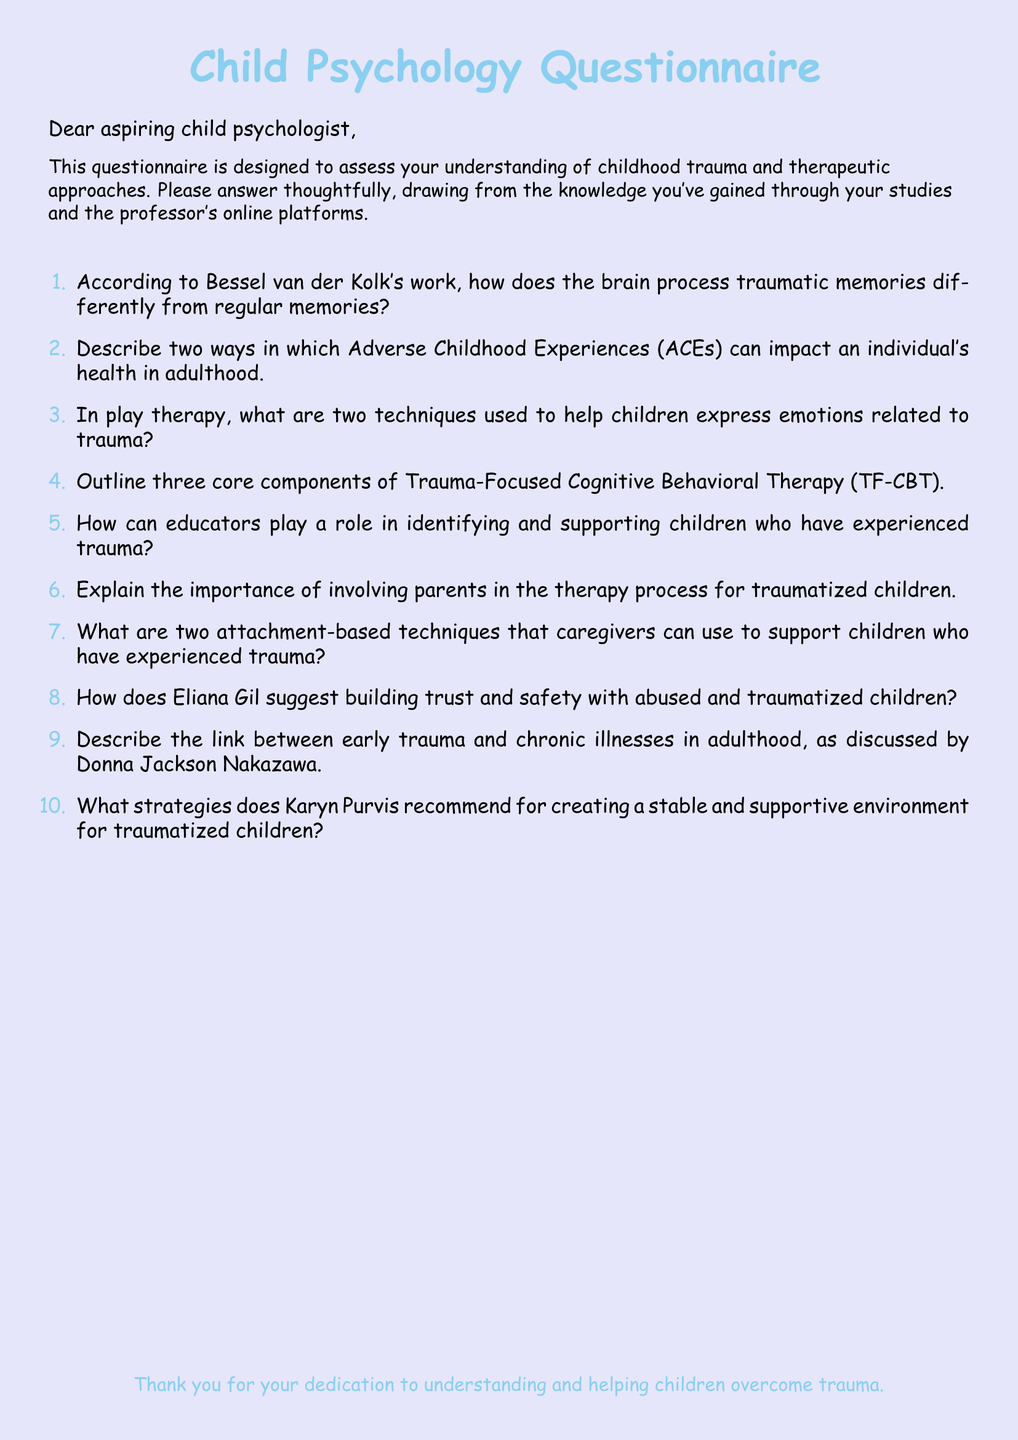What is the title of the document? The title is clearly stated at the beginning of the document, which is "Child Psychology Questionnaire."
Answer: Child Psychology Questionnaire Who is the audience for this questionnaire? The document specifically addresses "aspiring child psychologist," indicating who it is meant for.
Answer: aspiring child psychologist What color is used for the main font? The document uses "Comic Sans MS" as the main font for text.
Answer: Comic Sans MS What are ACEs? The term is mentioned in the context of "Adverse Childhood Experiences," which is abbreviated as ACEs.
Answer: Adverse Childhood Experiences How many questions are in the questionnaire? There are ten numbered questions listed in the document.
Answer: 10 What therapeutic approach is outlined in question four? The document references "Trauma-Focused Cognitive Behavioral Therapy" in question four.
Answer: Trauma-Focused Cognitive Behavioral Therapy What does the questionnaire encourage the respondents to draw from? The questionnaire suggests that respondents should answer based on the knowledge gained through their studies and the professor's online platforms.
Answer: knowledge gained through studies What does Eliana Gil focus on when working with children? The document inquires about how she builds trust and safety with abused and traumatized children, indicating her focus.
Answer: trust and safety What is highlighted as crucial for supporting traumatized children? The document emphasizes the importance of involving parents in the therapy process.
Answer: involving parents Who is referenced in the context of linking early trauma to chronic illnesses? The document attributes this concept to "Donna Jackson Nakazawa."
Answer: Donna Jackson Nakazawa 